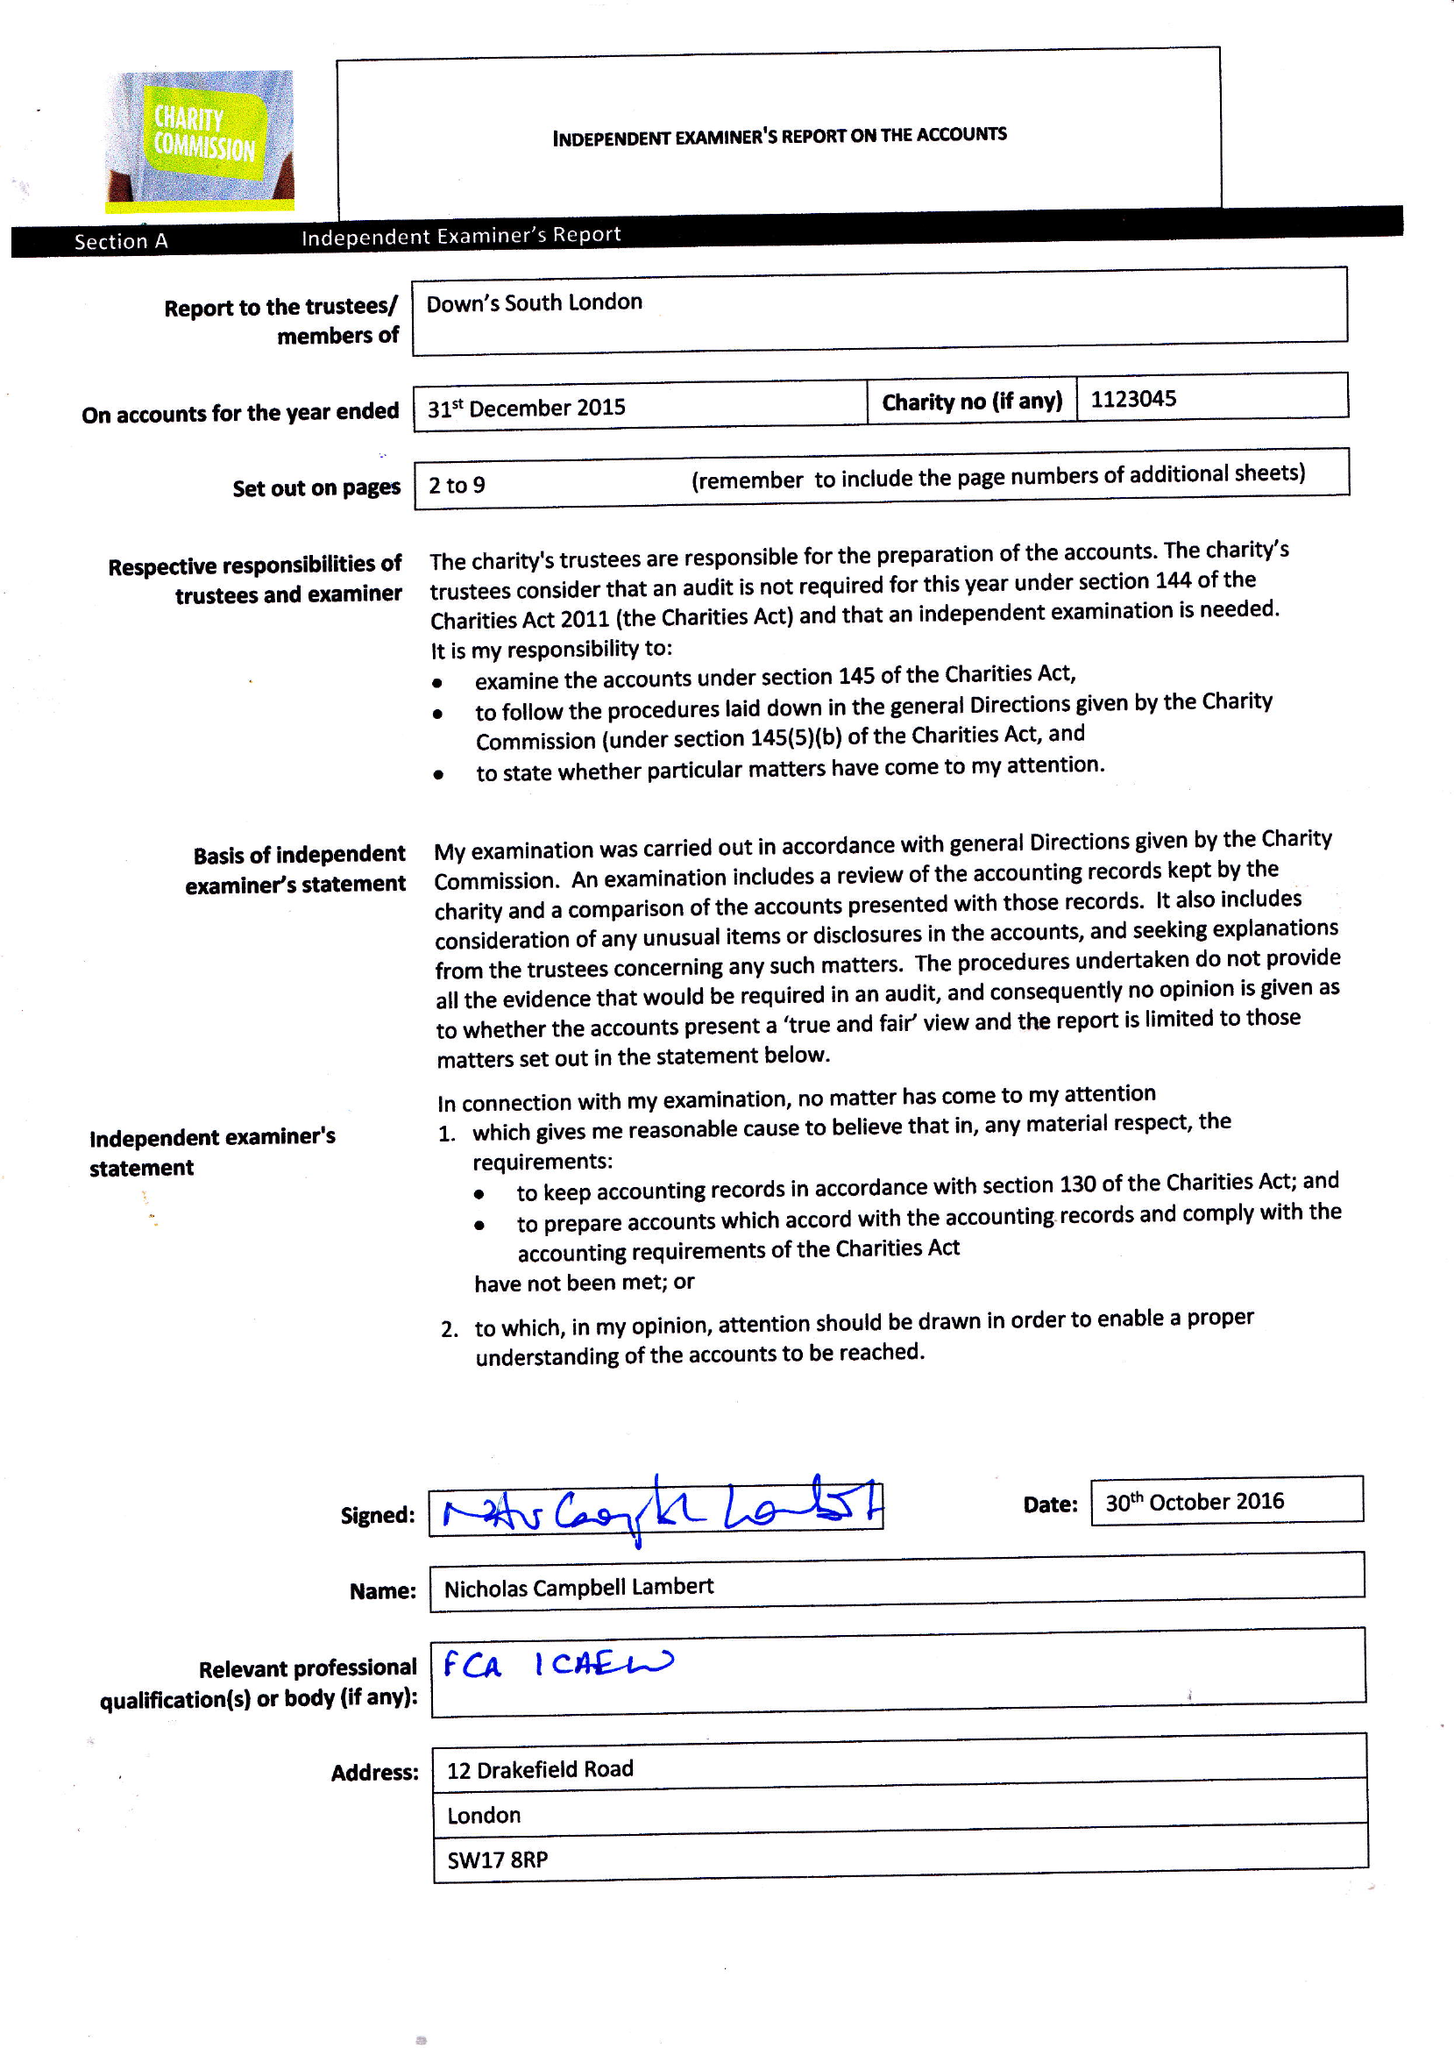What is the value for the spending_annually_in_british_pounds?
Answer the question using a single word or phrase. 97023.00 